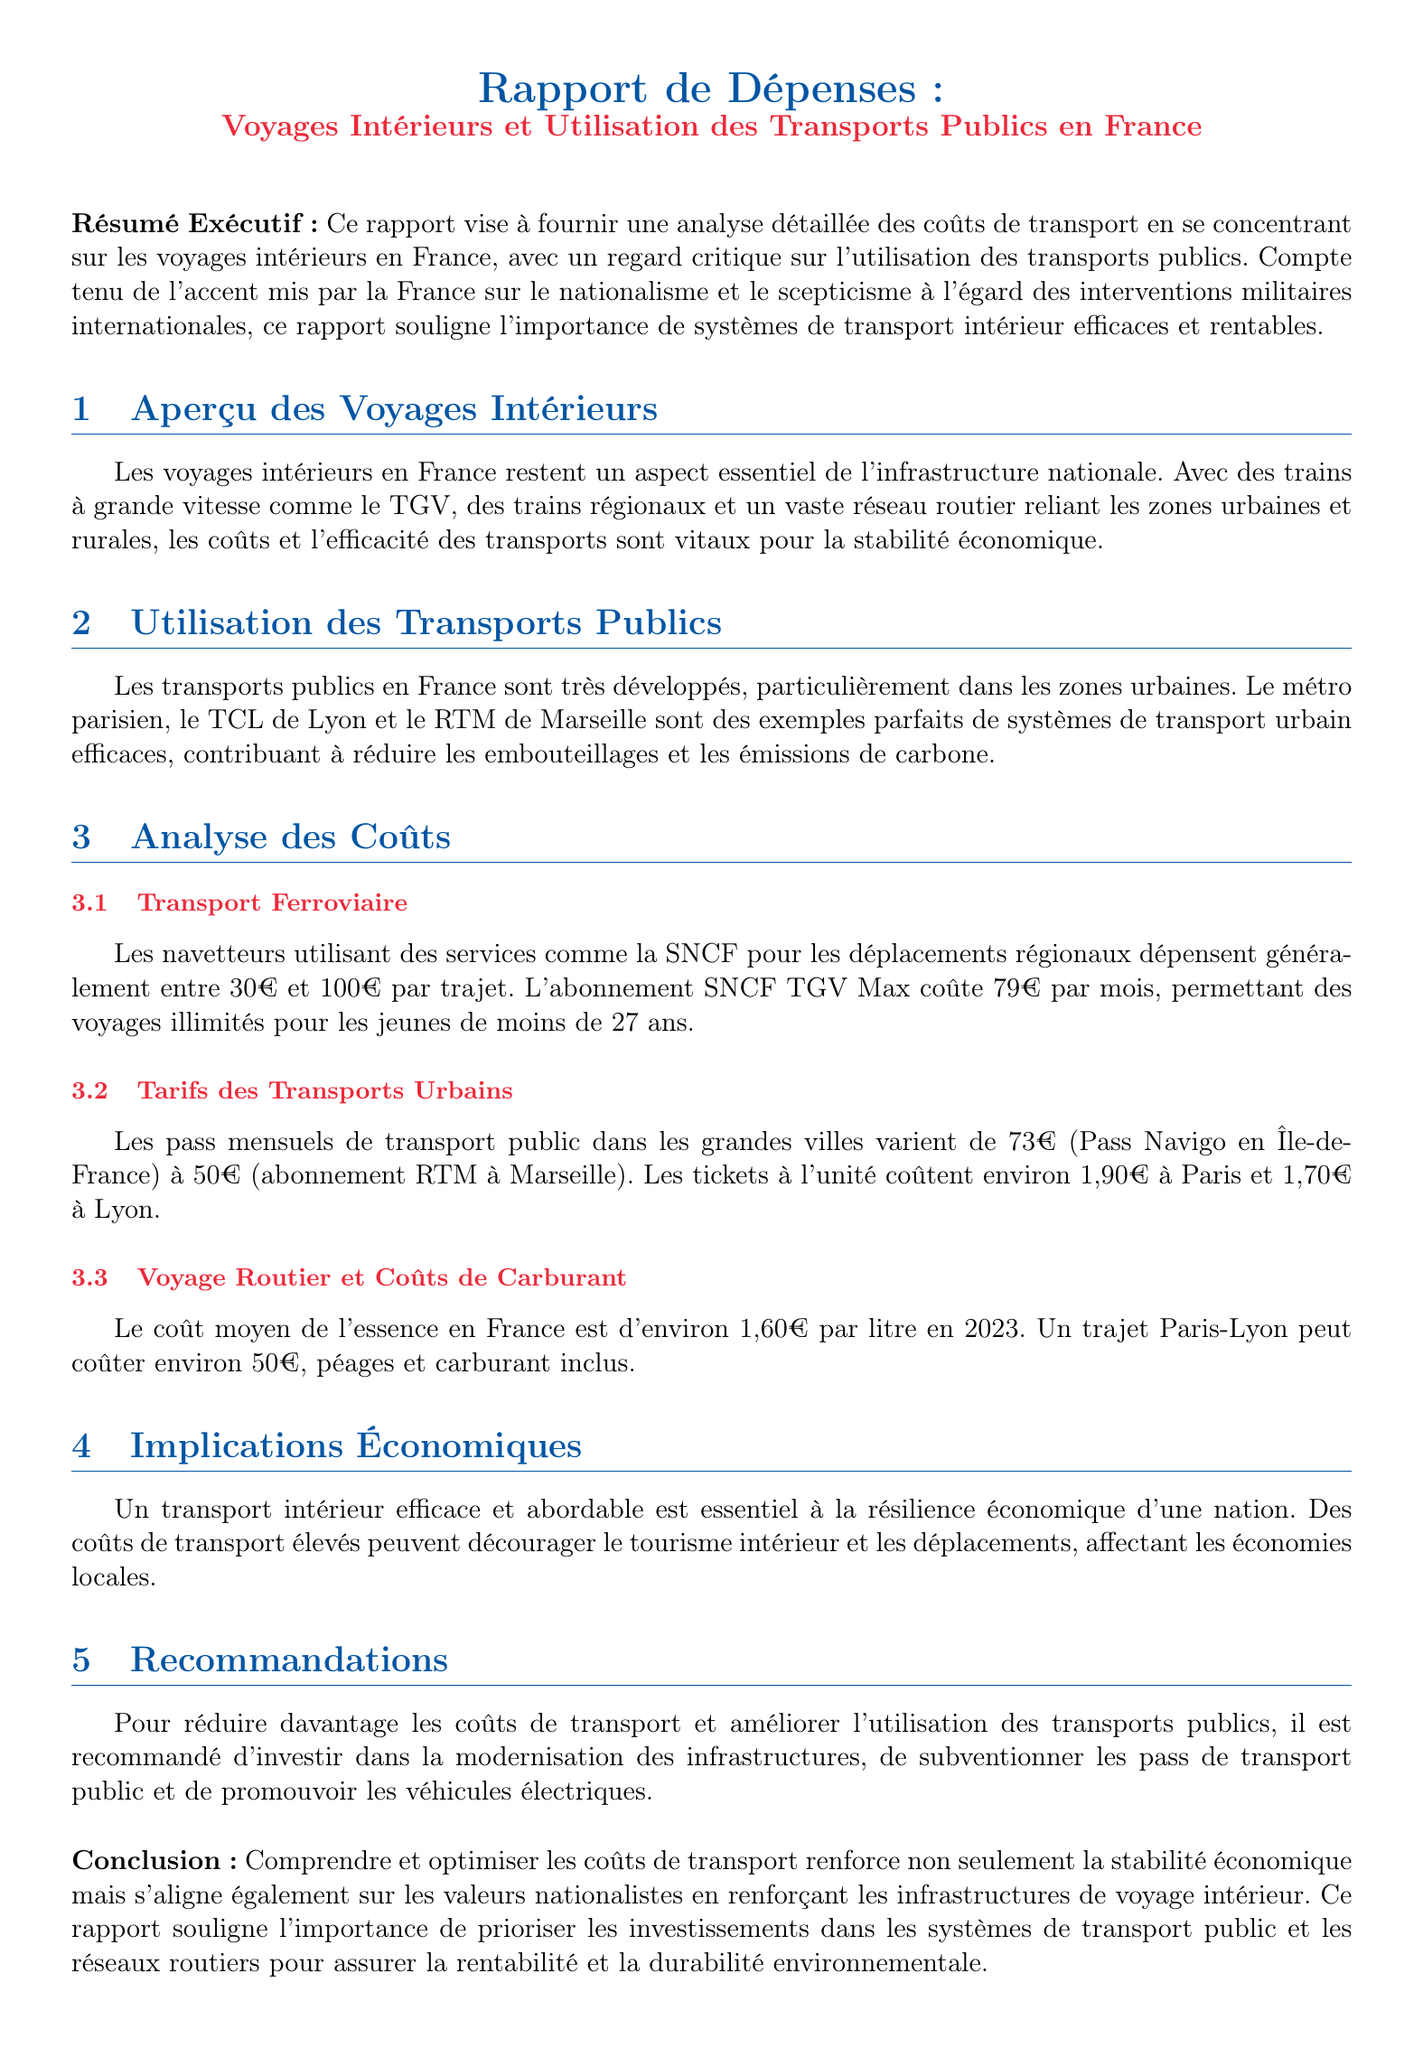Quel est le coût moyen de l'essence en France en 2023 ? Le coût moyen de l'essence en France est mentionné dans la section sur les coûts de transport routier.
Answer: 1,60€ Quel est le prix du Pass Navigo en Île-de-France ? Le Pass Navigo est indiqué comme ayant un tarif, ce qui reflète le coût des transports publics dans cette région.
Answer: 73€ Combien dépensent généralement les navetteurs pour un trajet en utilisant la SNCF ? La section sur le transport ferroviaire montre la fourchette de coûts pour les trajets SNCF.
Answer: entre 30€ et 100€ Quel abonnement SNCF permet des voyages illimités pour les jeunes ? L'abonnement adapté aux jeunes est précisé dans la section concernant le transport ferroviaire.
Answer: TGV Max Quelle ville est mentionnée comme ayant un exemple de transport urbain efficace en France ? L'exemple de transport urbain efficace est cité dans la section sur l'utilisation des transports publics.
Answer: Marseille Quel est le coût d'un ticket à l'unité à Paris ? Le document mentionne le coût des tickets à l'unité dans les grandes villes, y compris Paris.
Answer: 1,90€ Quel trajet routier coûte environ 50€ ? Le trajet spécifié dans la section sur les coûts de transport routier est mentionné pour illustrer les frais d'un voyage.
Answer: Paris-Lyon Comment l'optimisation des coûts de transport influence-t-elle l'économie locale ? La conclusion du rapport souligne l'importance des coûts de transport sur le tourisme intérieur et les déplacements.
Answer: Résilience économique 